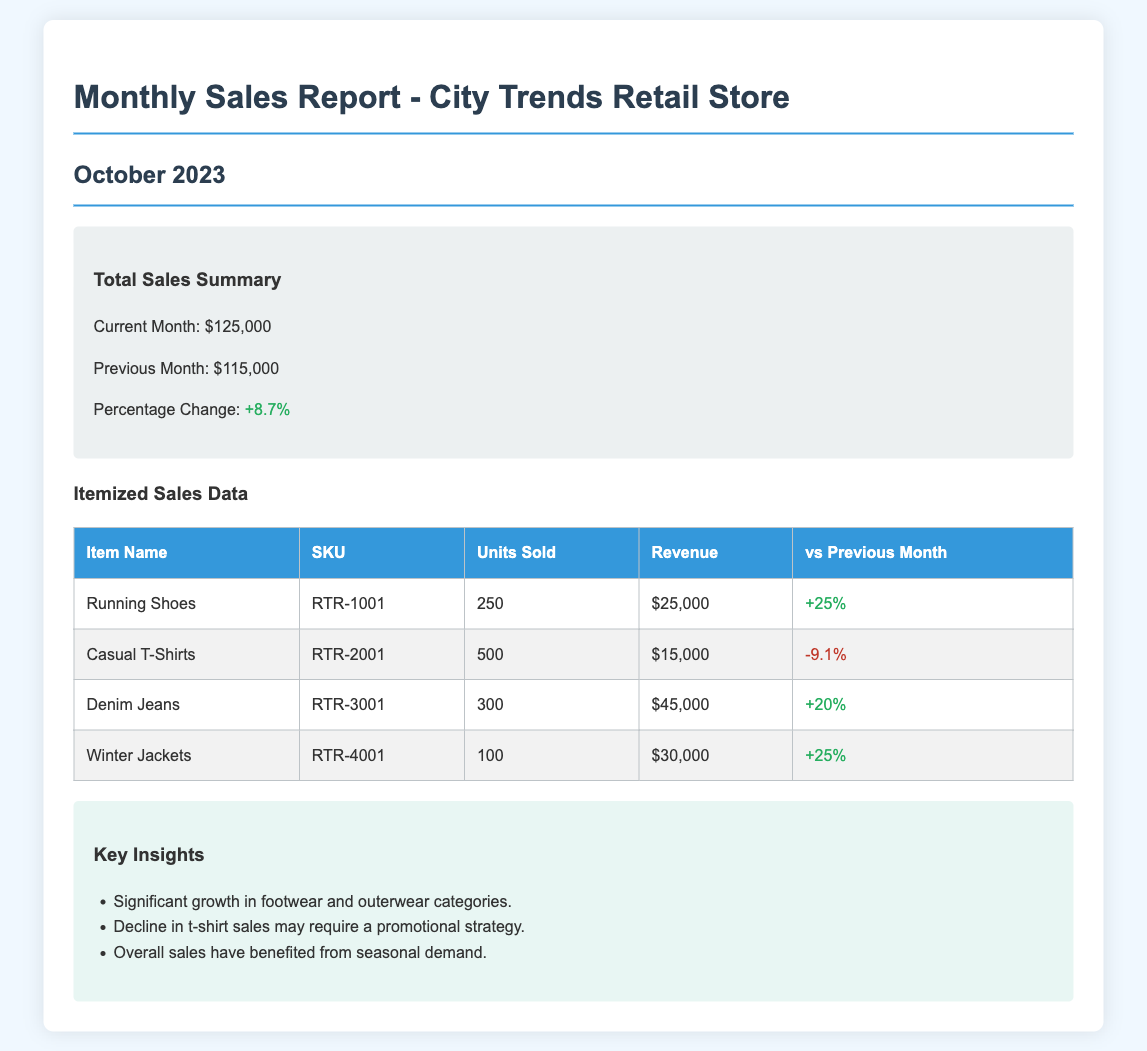What is the total sales for October 2023? The total sales for October 2023 is explicitly stated in the document.
Answer: $125,000 What was the previous month's total sales? The previous month's total sales is provided in the summary section of the document.
Answer: $115,000 What percentage change did the sales experience from last month? The document shows the percentage change in sales, which is calculated based on current and previous sales values.
Answer: +8.7% How many units of Running Shoes were sold? The itemized sales data table shows the number of units sold for each item, including Running Shoes.
Answer: 250 What is the revenue generated from Denim Jeans? The revenue for Denim Jeans is listed in the itemized sales data under the revenue column.
Answer: $45,000 What was the change in sales for Casual T-Shirts? The document details the change in sales for each item, including Casual T-Shirts, in percentage format.
Answer: -9.1% Which item had the highest revenue? By analyzing the revenue figures in the itemized sales data, we can identify which item earned the most.
Answer: Denim Jeans What insight suggests action for Casual T-Shirts? One of the insights provided discusses the need for a promotional strategy due to the decline in sales of Casual T-Shirts.
Answer: Promotional strategy What category showed significant growth? The insights section mentions specific categories that experienced significant growth, as per recent sales data.
Answer: Footwear and outerwear 